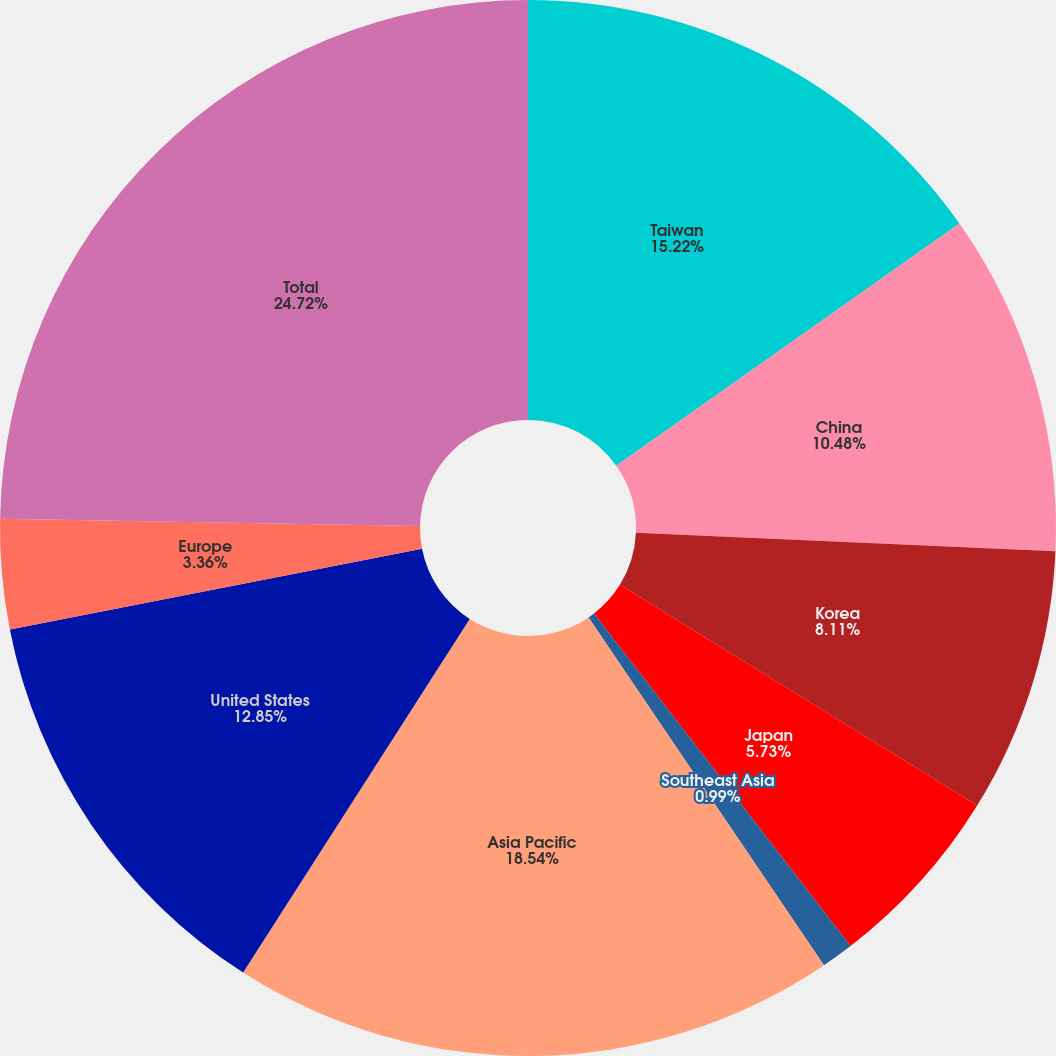Convert chart. <chart><loc_0><loc_0><loc_500><loc_500><pie_chart><fcel>Taiwan<fcel>China<fcel>Korea<fcel>Japan<fcel>Southeast Asia<fcel>Asia Pacific<fcel>United States<fcel>Europe<fcel>Total<nl><fcel>15.22%<fcel>10.48%<fcel>8.11%<fcel>5.73%<fcel>0.99%<fcel>18.54%<fcel>12.85%<fcel>3.36%<fcel>24.72%<nl></chart> 